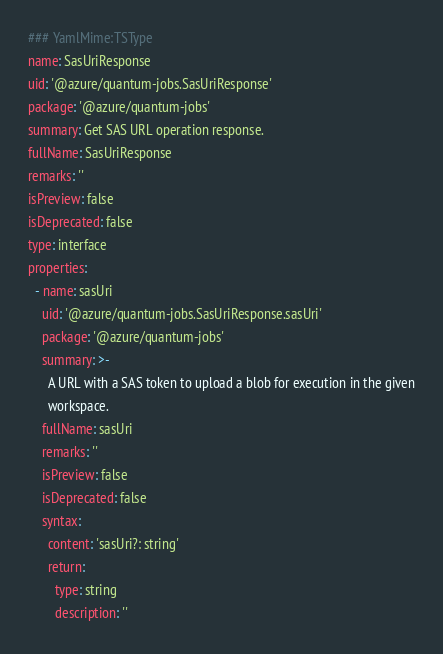Convert code to text. <code><loc_0><loc_0><loc_500><loc_500><_YAML_>### YamlMime:TSType
name: SasUriResponse
uid: '@azure/quantum-jobs.SasUriResponse'
package: '@azure/quantum-jobs'
summary: Get SAS URL operation response.
fullName: SasUriResponse
remarks: ''
isPreview: false
isDeprecated: false
type: interface
properties:
  - name: sasUri
    uid: '@azure/quantum-jobs.SasUriResponse.sasUri'
    package: '@azure/quantum-jobs'
    summary: >-
      A URL with a SAS token to upload a blob for execution in the given
      workspace.
    fullName: sasUri
    remarks: ''
    isPreview: false
    isDeprecated: false
    syntax:
      content: 'sasUri?: string'
      return:
        type: string
        description: ''
</code> 